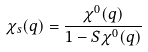Convert formula to latex. <formula><loc_0><loc_0><loc_500><loc_500>\chi _ { s } ( q ) = \frac { \chi ^ { 0 } ( q ) } { 1 - S \chi ^ { 0 } ( q ) }</formula> 